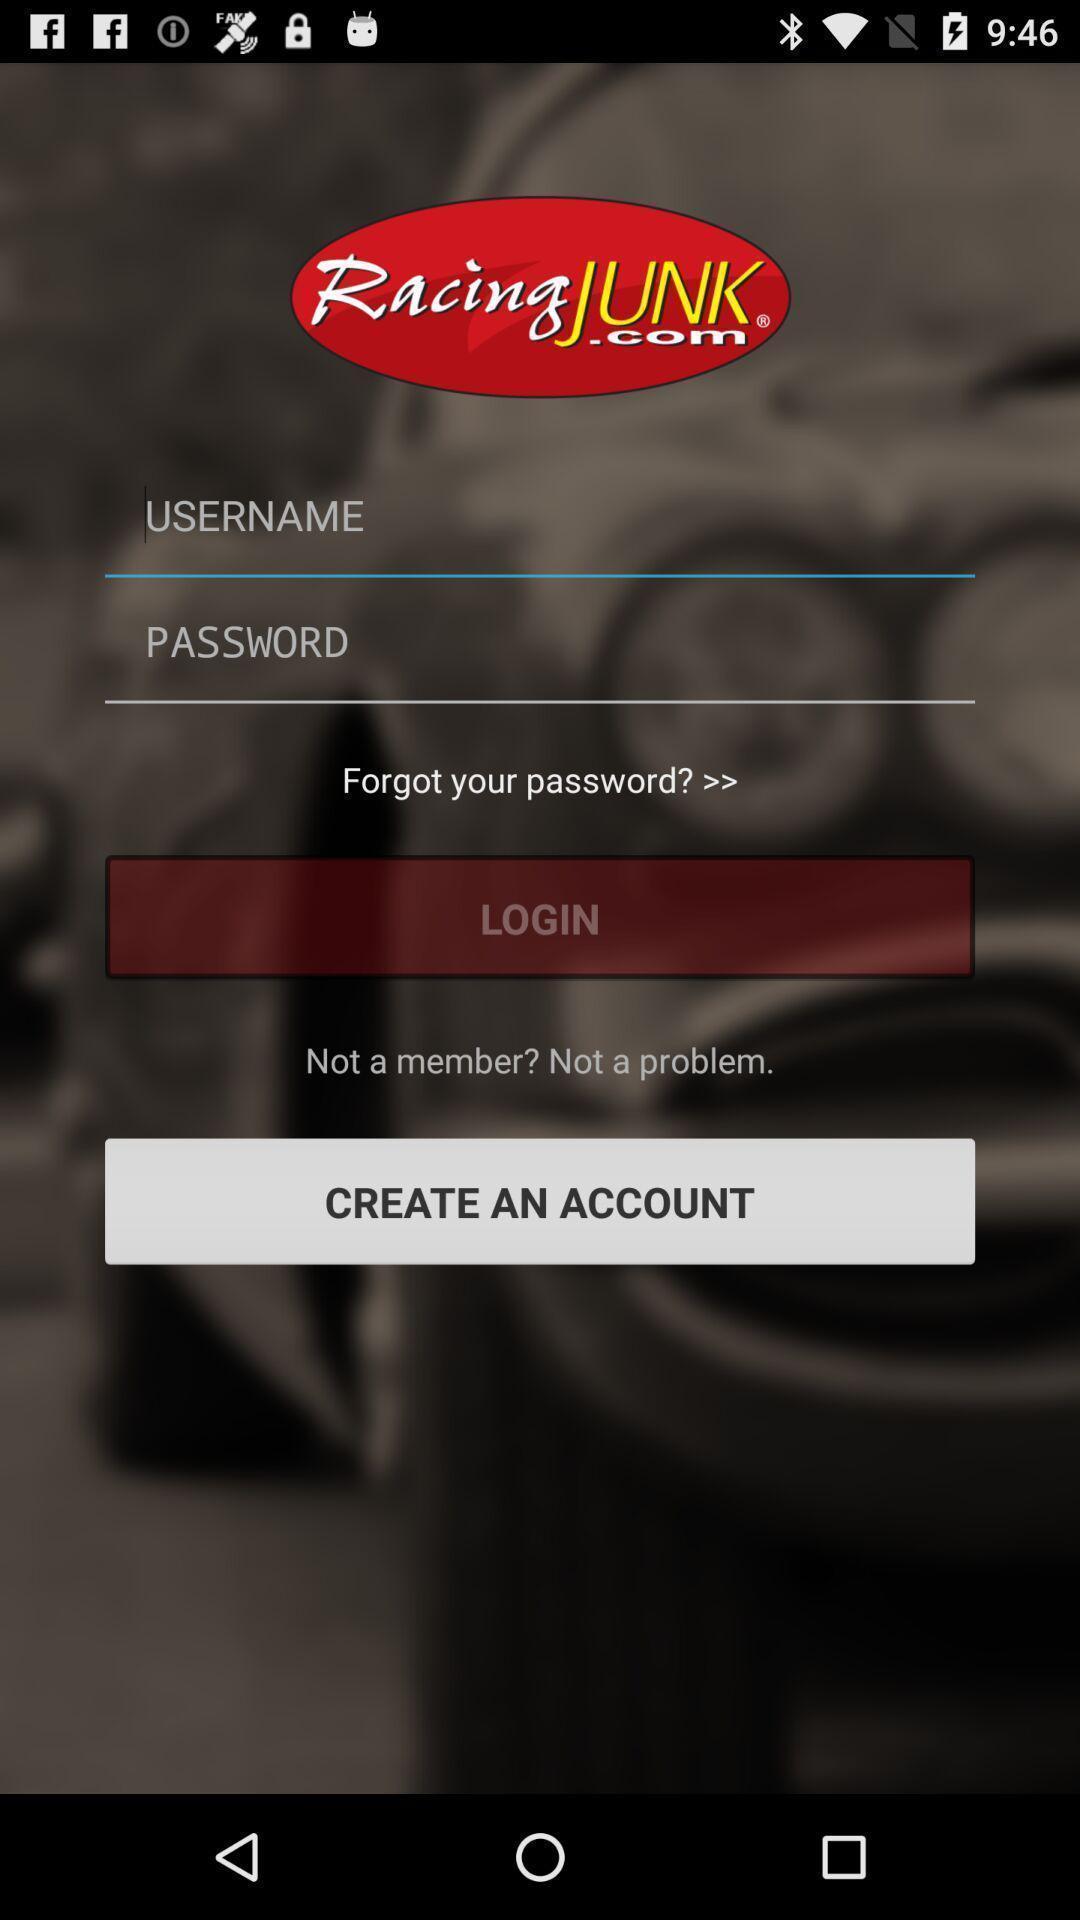Provide a detailed account of this screenshot. Screen displaying login page. 